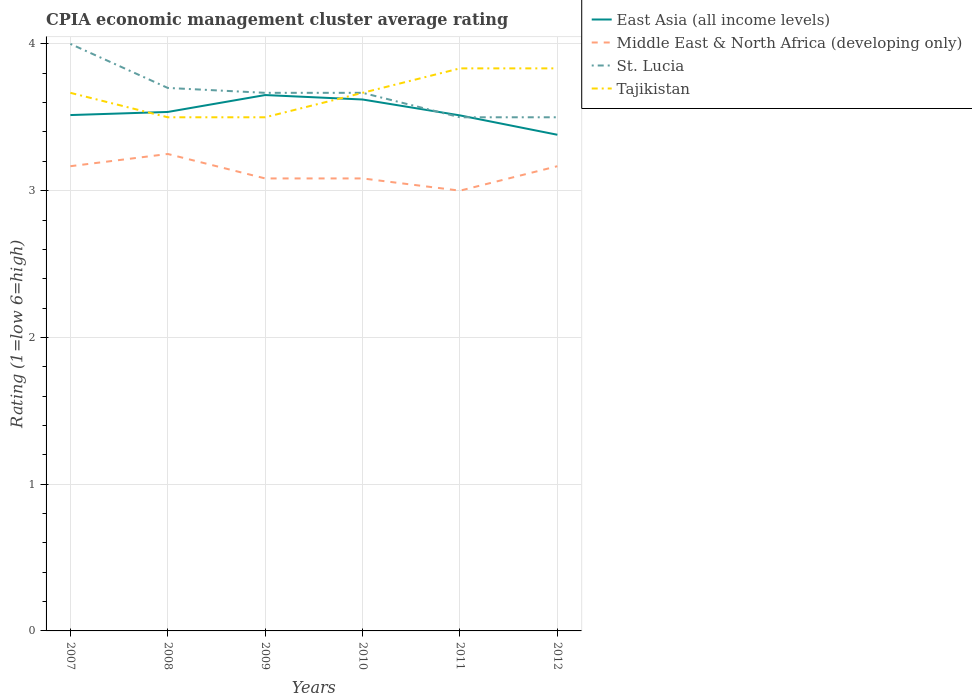Across all years, what is the maximum CPIA rating in St. Lucia?
Provide a short and direct response. 3.5. In which year was the CPIA rating in Middle East & North Africa (developing only) maximum?
Offer a terse response. 2011. What is the total CPIA rating in Tajikistan in the graph?
Give a very brief answer. -0.33. How many lines are there?
Your answer should be very brief. 4. How many years are there in the graph?
Your answer should be very brief. 6. Are the values on the major ticks of Y-axis written in scientific E-notation?
Give a very brief answer. No. Does the graph contain any zero values?
Provide a succinct answer. No. Where does the legend appear in the graph?
Your answer should be very brief. Top right. How many legend labels are there?
Your response must be concise. 4. What is the title of the graph?
Ensure brevity in your answer.  CPIA economic management cluster average rating. Does "Netherlands" appear as one of the legend labels in the graph?
Provide a succinct answer. No. What is the label or title of the X-axis?
Offer a terse response. Years. What is the Rating (1=low 6=high) of East Asia (all income levels) in 2007?
Your answer should be compact. 3.52. What is the Rating (1=low 6=high) of Middle East & North Africa (developing only) in 2007?
Your answer should be very brief. 3.17. What is the Rating (1=low 6=high) in Tajikistan in 2007?
Provide a succinct answer. 3.67. What is the Rating (1=low 6=high) of East Asia (all income levels) in 2008?
Your answer should be very brief. 3.54. What is the Rating (1=low 6=high) of St. Lucia in 2008?
Provide a short and direct response. 3.7. What is the Rating (1=low 6=high) in East Asia (all income levels) in 2009?
Your answer should be compact. 3.65. What is the Rating (1=low 6=high) in Middle East & North Africa (developing only) in 2009?
Your answer should be compact. 3.08. What is the Rating (1=low 6=high) in St. Lucia in 2009?
Give a very brief answer. 3.67. What is the Rating (1=low 6=high) of East Asia (all income levels) in 2010?
Keep it short and to the point. 3.62. What is the Rating (1=low 6=high) of Middle East & North Africa (developing only) in 2010?
Offer a very short reply. 3.08. What is the Rating (1=low 6=high) of St. Lucia in 2010?
Provide a succinct answer. 3.67. What is the Rating (1=low 6=high) of Tajikistan in 2010?
Your answer should be compact. 3.67. What is the Rating (1=low 6=high) of East Asia (all income levels) in 2011?
Provide a short and direct response. 3.51. What is the Rating (1=low 6=high) of St. Lucia in 2011?
Offer a very short reply. 3.5. What is the Rating (1=low 6=high) of Tajikistan in 2011?
Make the answer very short. 3.83. What is the Rating (1=low 6=high) of East Asia (all income levels) in 2012?
Ensure brevity in your answer.  3.38. What is the Rating (1=low 6=high) of Middle East & North Africa (developing only) in 2012?
Ensure brevity in your answer.  3.17. What is the Rating (1=low 6=high) in St. Lucia in 2012?
Provide a short and direct response. 3.5. What is the Rating (1=low 6=high) of Tajikistan in 2012?
Provide a short and direct response. 3.83. Across all years, what is the maximum Rating (1=low 6=high) in East Asia (all income levels)?
Offer a very short reply. 3.65. Across all years, what is the maximum Rating (1=low 6=high) of Tajikistan?
Provide a short and direct response. 3.83. Across all years, what is the minimum Rating (1=low 6=high) of East Asia (all income levels)?
Your answer should be very brief. 3.38. What is the total Rating (1=low 6=high) in East Asia (all income levels) in the graph?
Provide a short and direct response. 21.22. What is the total Rating (1=low 6=high) in Middle East & North Africa (developing only) in the graph?
Provide a short and direct response. 18.75. What is the total Rating (1=low 6=high) of St. Lucia in the graph?
Your response must be concise. 22.03. What is the difference between the Rating (1=low 6=high) of East Asia (all income levels) in 2007 and that in 2008?
Your answer should be compact. -0.02. What is the difference between the Rating (1=low 6=high) of Middle East & North Africa (developing only) in 2007 and that in 2008?
Make the answer very short. -0.08. What is the difference between the Rating (1=low 6=high) in Tajikistan in 2007 and that in 2008?
Offer a terse response. 0.17. What is the difference between the Rating (1=low 6=high) of East Asia (all income levels) in 2007 and that in 2009?
Your answer should be compact. -0.14. What is the difference between the Rating (1=low 6=high) of Middle East & North Africa (developing only) in 2007 and that in 2009?
Keep it short and to the point. 0.08. What is the difference between the Rating (1=low 6=high) of St. Lucia in 2007 and that in 2009?
Offer a very short reply. 0.33. What is the difference between the Rating (1=low 6=high) in East Asia (all income levels) in 2007 and that in 2010?
Provide a short and direct response. -0.11. What is the difference between the Rating (1=low 6=high) of Middle East & North Africa (developing only) in 2007 and that in 2010?
Keep it short and to the point. 0.08. What is the difference between the Rating (1=low 6=high) in St. Lucia in 2007 and that in 2010?
Your answer should be compact. 0.33. What is the difference between the Rating (1=low 6=high) of East Asia (all income levels) in 2007 and that in 2011?
Your answer should be very brief. 0. What is the difference between the Rating (1=low 6=high) in Middle East & North Africa (developing only) in 2007 and that in 2011?
Your answer should be compact. 0.17. What is the difference between the Rating (1=low 6=high) of St. Lucia in 2007 and that in 2011?
Ensure brevity in your answer.  0.5. What is the difference between the Rating (1=low 6=high) of East Asia (all income levels) in 2007 and that in 2012?
Offer a very short reply. 0.13. What is the difference between the Rating (1=low 6=high) in Tajikistan in 2007 and that in 2012?
Ensure brevity in your answer.  -0.17. What is the difference between the Rating (1=low 6=high) in East Asia (all income levels) in 2008 and that in 2009?
Provide a succinct answer. -0.12. What is the difference between the Rating (1=low 6=high) of St. Lucia in 2008 and that in 2009?
Offer a very short reply. 0.03. What is the difference between the Rating (1=low 6=high) in East Asia (all income levels) in 2008 and that in 2010?
Ensure brevity in your answer.  -0.08. What is the difference between the Rating (1=low 6=high) of St. Lucia in 2008 and that in 2010?
Give a very brief answer. 0.03. What is the difference between the Rating (1=low 6=high) in East Asia (all income levels) in 2008 and that in 2011?
Your answer should be compact. 0.02. What is the difference between the Rating (1=low 6=high) in Middle East & North Africa (developing only) in 2008 and that in 2011?
Provide a succinct answer. 0.25. What is the difference between the Rating (1=low 6=high) in St. Lucia in 2008 and that in 2011?
Offer a terse response. 0.2. What is the difference between the Rating (1=low 6=high) of Tajikistan in 2008 and that in 2011?
Give a very brief answer. -0.33. What is the difference between the Rating (1=low 6=high) of East Asia (all income levels) in 2008 and that in 2012?
Make the answer very short. 0.16. What is the difference between the Rating (1=low 6=high) of Middle East & North Africa (developing only) in 2008 and that in 2012?
Offer a terse response. 0.08. What is the difference between the Rating (1=low 6=high) in Tajikistan in 2008 and that in 2012?
Offer a terse response. -0.33. What is the difference between the Rating (1=low 6=high) in East Asia (all income levels) in 2009 and that in 2010?
Your answer should be compact. 0.03. What is the difference between the Rating (1=low 6=high) of Middle East & North Africa (developing only) in 2009 and that in 2010?
Ensure brevity in your answer.  0. What is the difference between the Rating (1=low 6=high) in Tajikistan in 2009 and that in 2010?
Keep it short and to the point. -0.17. What is the difference between the Rating (1=low 6=high) in East Asia (all income levels) in 2009 and that in 2011?
Your answer should be compact. 0.14. What is the difference between the Rating (1=low 6=high) in Middle East & North Africa (developing only) in 2009 and that in 2011?
Keep it short and to the point. 0.08. What is the difference between the Rating (1=low 6=high) in East Asia (all income levels) in 2009 and that in 2012?
Offer a very short reply. 0.27. What is the difference between the Rating (1=low 6=high) in Middle East & North Africa (developing only) in 2009 and that in 2012?
Your response must be concise. -0.08. What is the difference between the Rating (1=low 6=high) in St. Lucia in 2009 and that in 2012?
Offer a very short reply. 0.17. What is the difference between the Rating (1=low 6=high) in East Asia (all income levels) in 2010 and that in 2011?
Keep it short and to the point. 0.11. What is the difference between the Rating (1=low 6=high) in Middle East & North Africa (developing only) in 2010 and that in 2011?
Offer a terse response. 0.08. What is the difference between the Rating (1=low 6=high) in St. Lucia in 2010 and that in 2011?
Keep it short and to the point. 0.17. What is the difference between the Rating (1=low 6=high) of East Asia (all income levels) in 2010 and that in 2012?
Offer a terse response. 0.24. What is the difference between the Rating (1=low 6=high) of Middle East & North Africa (developing only) in 2010 and that in 2012?
Make the answer very short. -0.08. What is the difference between the Rating (1=low 6=high) of St. Lucia in 2010 and that in 2012?
Your response must be concise. 0.17. What is the difference between the Rating (1=low 6=high) of Tajikistan in 2010 and that in 2012?
Provide a short and direct response. -0.17. What is the difference between the Rating (1=low 6=high) in East Asia (all income levels) in 2011 and that in 2012?
Your answer should be compact. 0.13. What is the difference between the Rating (1=low 6=high) in St. Lucia in 2011 and that in 2012?
Give a very brief answer. 0. What is the difference between the Rating (1=low 6=high) in East Asia (all income levels) in 2007 and the Rating (1=low 6=high) in Middle East & North Africa (developing only) in 2008?
Provide a succinct answer. 0.27. What is the difference between the Rating (1=low 6=high) in East Asia (all income levels) in 2007 and the Rating (1=low 6=high) in St. Lucia in 2008?
Provide a succinct answer. -0.18. What is the difference between the Rating (1=low 6=high) of East Asia (all income levels) in 2007 and the Rating (1=low 6=high) of Tajikistan in 2008?
Make the answer very short. 0.02. What is the difference between the Rating (1=low 6=high) of Middle East & North Africa (developing only) in 2007 and the Rating (1=low 6=high) of St. Lucia in 2008?
Offer a very short reply. -0.53. What is the difference between the Rating (1=low 6=high) in Middle East & North Africa (developing only) in 2007 and the Rating (1=low 6=high) in Tajikistan in 2008?
Give a very brief answer. -0.33. What is the difference between the Rating (1=low 6=high) of St. Lucia in 2007 and the Rating (1=low 6=high) of Tajikistan in 2008?
Give a very brief answer. 0.5. What is the difference between the Rating (1=low 6=high) in East Asia (all income levels) in 2007 and the Rating (1=low 6=high) in Middle East & North Africa (developing only) in 2009?
Your answer should be very brief. 0.43. What is the difference between the Rating (1=low 6=high) in East Asia (all income levels) in 2007 and the Rating (1=low 6=high) in St. Lucia in 2009?
Your response must be concise. -0.15. What is the difference between the Rating (1=low 6=high) in East Asia (all income levels) in 2007 and the Rating (1=low 6=high) in Tajikistan in 2009?
Give a very brief answer. 0.02. What is the difference between the Rating (1=low 6=high) in Middle East & North Africa (developing only) in 2007 and the Rating (1=low 6=high) in Tajikistan in 2009?
Make the answer very short. -0.33. What is the difference between the Rating (1=low 6=high) of East Asia (all income levels) in 2007 and the Rating (1=low 6=high) of Middle East & North Africa (developing only) in 2010?
Offer a terse response. 0.43. What is the difference between the Rating (1=low 6=high) of East Asia (all income levels) in 2007 and the Rating (1=low 6=high) of St. Lucia in 2010?
Your response must be concise. -0.15. What is the difference between the Rating (1=low 6=high) of East Asia (all income levels) in 2007 and the Rating (1=low 6=high) of Tajikistan in 2010?
Your answer should be compact. -0.15. What is the difference between the Rating (1=low 6=high) of Middle East & North Africa (developing only) in 2007 and the Rating (1=low 6=high) of Tajikistan in 2010?
Your answer should be very brief. -0.5. What is the difference between the Rating (1=low 6=high) of St. Lucia in 2007 and the Rating (1=low 6=high) of Tajikistan in 2010?
Your response must be concise. 0.33. What is the difference between the Rating (1=low 6=high) of East Asia (all income levels) in 2007 and the Rating (1=low 6=high) of Middle East & North Africa (developing only) in 2011?
Offer a very short reply. 0.52. What is the difference between the Rating (1=low 6=high) in East Asia (all income levels) in 2007 and the Rating (1=low 6=high) in St. Lucia in 2011?
Offer a terse response. 0.02. What is the difference between the Rating (1=low 6=high) in East Asia (all income levels) in 2007 and the Rating (1=low 6=high) in Tajikistan in 2011?
Ensure brevity in your answer.  -0.32. What is the difference between the Rating (1=low 6=high) in Middle East & North Africa (developing only) in 2007 and the Rating (1=low 6=high) in Tajikistan in 2011?
Provide a short and direct response. -0.67. What is the difference between the Rating (1=low 6=high) in East Asia (all income levels) in 2007 and the Rating (1=low 6=high) in Middle East & North Africa (developing only) in 2012?
Offer a terse response. 0.35. What is the difference between the Rating (1=low 6=high) in East Asia (all income levels) in 2007 and the Rating (1=low 6=high) in St. Lucia in 2012?
Your answer should be very brief. 0.02. What is the difference between the Rating (1=low 6=high) in East Asia (all income levels) in 2007 and the Rating (1=low 6=high) in Tajikistan in 2012?
Give a very brief answer. -0.32. What is the difference between the Rating (1=low 6=high) in Middle East & North Africa (developing only) in 2007 and the Rating (1=low 6=high) in Tajikistan in 2012?
Your response must be concise. -0.67. What is the difference between the Rating (1=low 6=high) in East Asia (all income levels) in 2008 and the Rating (1=low 6=high) in Middle East & North Africa (developing only) in 2009?
Make the answer very short. 0.45. What is the difference between the Rating (1=low 6=high) of East Asia (all income levels) in 2008 and the Rating (1=low 6=high) of St. Lucia in 2009?
Give a very brief answer. -0.13. What is the difference between the Rating (1=low 6=high) of East Asia (all income levels) in 2008 and the Rating (1=low 6=high) of Tajikistan in 2009?
Give a very brief answer. 0.04. What is the difference between the Rating (1=low 6=high) in Middle East & North Africa (developing only) in 2008 and the Rating (1=low 6=high) in St. Lucia in 2009?
Provide a succinct answer. -0.42. What is the difference between the Rating (1=low 6=high) in St. Lucia in 2008 and the Rating (1=low 6=high) in Tajikistan in 2009?
Ensure brevity in your answer.  0.2. What is the difference between the Rating (1=low 6=high) in East Asia (all income levels) in 2008 and the Rating (1=low 6=high) in Middle East & North Africa (developing only) in 2010?
Offer a terse response. 0.45. What is the difference between the Rating (1=low 6=high) of East Asia (all income levels) in 2008 and the Rating (1=low 6=high) of St. Lucia in 2010?
Provide a succinct answer. -0.13. What is the difference between the Rating (1=low 6=high) in East Asia (all income levels) in 2008 and the Rating (1=low 6=high) in Tajikistan in 2010?
Give a very brief answer. -0.13. What is the difference between the Rating (1=low 6=high) in Middle East & North Africa (developing only) in 2008 and the Rating (1=low 6=high) in St. Lucia in 2010?
Your answer should be compact. -0.42. What is the difference between the Rating (1=low 6=high) in Middle East & North Africa (developing only) in 2008 and the Rating (1=low 6=high) in Tajikistan in 2010?
Provide a succinct answer. -0.42. What is the difference between the Rating (1=low 6=high) in East Asia (all income levels) in 2008 and the Rating (1=low 6=high) in Middle East & North Africa (developing only) in 2011?
Give a very brief answer. 0.54. What is the difference between the Rating (1=low 6=high) in East Asia (all income levels) in 2008 and the Rating (1=low 6=high) in St. Lucia in 2011?
Your answer should be compact. 0.04. What is the difference between the Rating (1=low 6=high) of East Asia (all income levels) in 2008 and the Rating (1=low 6=high) of Tajikistan in 2011?
Ensure brevity in your answer.  -0.3. What is the difference between the Rating (1=low 6=high) in Middle East & North Africa (developing only) in 2008 and the Rating (1=low 6=high) in St. Lucia in 2011?
Offer a very short reply. -0.25. What is the difference between the Rating (1=low 6=high) of Middle East & North Africa (developing only) in 2008 and the Rating (1=low 6=high) of Tajikistan in 2011?
Offer a terse response. -0.58. What is the difference between the Rating (1=low 6=high) in St. Lucia in 2008 and the Rating (1=low 6=high) in Tajikistan in 2011?
Ensure brevity in your answer.  -0.13. What is the difference between the Rating (1=low 6=high) in East Asia (all income levels) in 2008 and the Rating (1=low 6=high) in Middle East & North Africa (developing only) in 2012?
Give a very brief answer. 0.37. What is the difference between the Rating (1=low 6=high) in East Asia (all income levels) in 2008 and the Rating (1=low 6=high) in St. Lucia in 2012?
Provide a succinct answer. 0.04. What is the difference between the Rating (1=low 6=high) of East Asia (all income levels) in 2008 and the Rating (1=low 6=high) of Tajikistan in 2012?
Ensure brevity in your answer.  -0.3. What is the difference between the Rating (1=low 6=high) in Middle East & North Africa (developing only) in 2008 and the Rating (1=low 6=high) in St. Lucia in 2012?
Keep it short and to the point. -0.25. What is the difference between the Rating (1=low 6=high) of Middle East & North Africa (developing only) in 2008 and the Rating (1=low 6=high) of Tajikistan in 2012?
Provide a short and direct response. -0.58. What is the difference between the Rating (1=low 6=high) of St. Lucia in 2008 and the Rating (1=low 6=high) of Tajikistan in 2012?
Your answer should be compact. -0.13. What is the difference between the Rating (1=low 6=high) of East Asia (all income levels) in 2009 and the Rating (1=low 6=high) of Middle East & North Africa (developing only) in 2010?
Your answer should be very brief. 0.57. What is the difference between the Rating (1=low 6=high) in East Asia (all income levels) in 2009 and the Rating (1=low 6=high) in St. Lucia in 2010?
Provide a short and direct response. -0.02. What is the difference between the Rating (1=low 6=high) in East Asia (all income levels) in 2009 and the Rating (1=low 6=high) in Tajikistan in 2010?
Provide a short and direct response. -0.02. What is the difference between the Rating (1=low 6=high) of Middle East & North Africa (developing only) in 2009 and the Rating (1=low 6=high) of St. Lucia in 2010?
Provide a succinct answer. -0.58. What is the difference between the Rating (1=low 6=high) of Middle East & North Africa (developing only) in 2009 and the Rating (1=low 6=high) of Tajikistan in 2010?
Your response must be concise. -0.58. What is the difference between the Rating (1=low 6=high) of East Asia (all income levels) in 2009 and the Rating (1=low 6=high) of Middle East & North Africa (developing only) in 2011?
Ensure brevity in your answer.  0.65. What is the difference between the Rating (1=low 6=high) of East Asia (all income levels) in 2009 and the Rating (1=low 6=high) of St. Lucia in 2011?
Your response must be concise. 0.15. What is the difference between the Rating (1=low 6=high) of East Asia (all income levels) in 2009 and the Rating (1=low 6=high) of Tajikistan in 2011?
Keep it short and to the point. -0.18. What is the difference between the Rating (1=low 6=high) of Middle East & North Africa (developing only) in 2009 and the Rating (1=low 6=high) of St. Lucia in 2011?
Ensure brevity in your answer.  -0.42. What is the difference between the Rating (1=low 6=high) in Middle East & North Africa (developing only) in 2009 and the Rating (1=low 6=high) in Tajikistan in 2011?
Make the answer very short. -0.75. What is the difference between the Rating (1=low 6=high) in East Asia (all income levels) in 2009 and the Rating (1=low 6=high) in Middle East & North Africa (developing only) in 2012?
Your response must be concise. 0.48. What is the difference between the Rating (1=low 6=high) of East Asia (all income levels) in 2009 and the Rating (1=low 6=high) of St. Lucia in 2012?
Ensure brevity in your answer.  0.15. What is the difference between the Rating (1=low 6=high) in East Asia (all income levels) in 2009 and the Rating (1=low 6=high) in Tajikistan in 2012?
Offer a very short reply. -0.18. What is the difference between the Rating (1=low 6=high) in Middle East & North Africa (developing only) in 2009 and the Rating (1=low 6=high) in St. Lucia in 2012?
Provide a short and direct response. -0.42. What is the difference between the Rating (1=low 6=high) of Middle East & North Africa (developing only) in 2009 and the Rating (1=low 6=high) of Tajikistan in 2012?
Your response must be concise. -0.75. What is the difference between the Rating (1=low 6=high) in St. Lucia in 2009 and the Rating (1=low 6=high) in Tajikistan in 2012?
Your answer should be very brief. -0.17. What is the difference between the Rating (1=low 6=high) in East Asia (all income levels) in 2010 and the Rating (1=low 6=high) in Middle East & North Africa (developing only) in 2011?
Provide a short and direct response. 0.62. What is the difference between the Rating (1=low 6=high) of East Asia (all income levels) in 2010 and the Rating (1=low 6=high) of St. Lucia in 2011?
Offer a terse response. 0.12. What is the difference between the Rating (1=low 6=high) of East Asia (all income levels) in 2010 and the Rating (1=low 6=high) of Tajikistan in 2011?
Your answer should be compact. -0.21. What is the difference between the Rating (1=low 6=high) of Middle East & North Africa (developing only) in 2010 and the Rating (1=low 6=high) of St. Lucia in 2011?
Your answer should be very brief. -0.42. What is the difference between the Rating (1=low 6=high) in Middle East & North Africa (developing only) in 2010 and the Rating (1=low 6=high) in Tajikistan in 2011?
Your answer should be very brief. -0.75. What is the difference between the Rating (1=low 6=high) of East Asia (all income levels) in 2010 and the Rating (1=low 6=high) of Middle East & North Africa (developing only) in 2012?
Your response must be concise. 0.45. What is the difference between the Rating (1=low 6=high) in East Asia (all income levels) in 2010 and the Rating (1=low 6=high) in St. Lucia in 2012?
Keep it short and to the point. 0.12. What is the difference between the Rating (1=low 6=high) in East Asia (all income levels) in 2010 and the Rating (1=low 6=high) in Tajikistan in 2012?
Your response must be concise. -0.21. What is the difference between the Rating (1=low 6=high) of Middle East & North Africa (developing only) in 2010 and the Rating (1=low 6=high) of St. Lucia in 2012?
Your response must be concise. -0.42. What is the difference between the Rating (1=low 6=high) of Middle East & North Africa (developing only) in 2010 and the Rating (1=low 6=high) of Tajikistan in 2012?
Offer a very short reply. -0.75. What is the difference between the Rating (1=low 6=high) of East Asia (all income levels) in 2011 and the Rating (1=low 6=high) of Middle East & North Africa (developing only) in 2012?
Keep it short and to the point. 0.35. What is the difference between the Rating (1=low 6=high) of East Asia (all income levels) in 2011 and the Rating (1=low 6=high) of St. Lucia in 2012?
Your response must be concise. 0.01. What is the difference between the Rating (1=low 6=high) of East Asia (all income levels) in 2011 and the Rating (1=low 6=high) of Tajikistan in 2012?
Keep it short and to the point. -0.32. What is the difference between the Rating (1=low 6=high) of Middle East & North Africa (developing only) in 2011 and the Rating (1=low 6=high) of Tajikistan in 2012?
Give a very brief answer. -0.83. What is the average Rating (1=low 6=high) of East Asia (all income levels) per year?
Your answer should be very brief. 3.54. What is the average Rating (1=low 6=high) of Middle East & North Africa (developing only) per year?
Provide a short and direct response. 3.12. What is the average Rating (1=low 6=high) in St. Lucia per year?
Your answer should be very brief. 3.67. What is the average Rating (1=low 6=high) of Tajikistan per year?
Offer a very short reply. 3.67. In the year 2007, what is the difference between the Rating (1=low 6=high) of East Asia (all income levels) and Rating (1=low 6=high) of Middle East & North Africa (developing only)?
Offer a terse response. 0.35. In the year 2007, what is the difference between the Rating (1=low 6=high) of East Asia (all income levels) and Rating (1=low 6=high) of St. Lucia?
Your answer should be very brief. -0.48. In the year 2007, what is the difference between the Rating (1=low 6=high) in East Asia (all income levels) and Rating (1=low 6=high) in Tajikistan?
Your answer should be compact. -0.15. In the year 2007, what is the difference between the Rating (1=low 6=high) of Middle East & North Africa (developing only) and Rating (1=low 6=high) of Tajikistan?
Your response must be concise. -0.5. In the year 2007, what is the difference between the Rating (1=low 6=high) of St. Lucia and Rating (1=low 6=high) of Tajikistan?
Offer a very short reply. 0.33. In the year 2008, what is the difference between the Rating (1=low 6=high) in East Asia (all income levels) and Rating (1=low 6=high) in Middle East & North Africa (developing only)?
Give a very brief answer. 0.29. In the year 2008, what is the difference between the Rating (1=low 6=high) in East Asia (all income levels) and Rating (1=low 6=high) in St. Lucia?
Keep it short and to the point. -0.16. In the year 2008, what is the difference between the Rating (1=low 6=high) of East Asia (all income levels) and Rating (1=low 6=high) of Tajikistan?
Give a very brief answer. 0.04. In the year 2008, what is the difference between the Rating (1=low 6=high) in Middle East & North Africa (developing only) and Rating (1=low 6=high) in St. Lucia?
Make the answer very short. -0.45. In the year 2008, what is the difference between the Rating (1=low 6=high) of St. Lucia and Rating (1=low 6=high) of Tajikistan?
Offer a terse response. 0.2. In the year 2009, what is the difference between the Rating (1=low 6=high) of East Asia (all income levels) and Rating (1=low 6=high) of Middle East & North Africa (developing only)?
Keep it short and to the point. 0.57. In the year 2009, what is the difference between the Rating (1=low 6=high) of East Asia (all income levels) and Rating (1=low 6=high) of St. Lucia?
Provide a short and direct response. -0.02. In the year 2009, what is the difference between the Rating (1=low 6=high) in East Asia (all income levels) and Rating (1=low 6=high) in Tajikistan?
Make the answer very short. 0.15. In the year 2009, what is the difference between the Rating (1=low 6=high) in Middle East & North Africa (developing only) and Rating (1=low 6=high) in St. Lucia?
Your answer should be very brief. -0.58. In the year 2009, what is the difference between the Rating (1=low 6=high) in Middle East & North Africa (developing only) and Rating (1=low 6=high) in Tajikistan?
Keep it short and to the point. -0.42. In the year 2010, what is the difference between the Rating (1=low 6=high) of East Asia (all income levels) and Rating (1=low 6=high) of Middle East & North Africa (developing only)?
Make the answer very short. 0.54. In the year 2010, what is the difference between the Rating (1=low 6=high) in East Asia (all income levels) and Rating (1=low 6=high) in St. Lucia?
Make the answer very short. -0.05. In the year 2010, what is the difference between the Rating (1=low 6=high) of East Asia (all income levels) and Rating (1=low 6=high) of Tajikistan?
Your response must be concise. -0.05. In the year 2010, what is the difference between the Rating (1=low 6=high) in Middle East & North Africa (developing only) and Rating (1=low 6=high) in St. Lucia?
Provide a short and direct response. -0.58. In the year 2010, what is the difference between the Rating (1=low 6=high) of Middle East & North Africa (developing only) and Rating (1=low 6=high) of Tajikistan?
Your answer should be very brief. -0.58. In the year 2010, what is the difference between the Rating (1=low 6=high) in St. Lucia and Rating (1=low 6=high) in Tajikistan?
Provide a succinct answer. 0. In the year 2011, what is the difference between the Rating (1=low 6=high) in East Asia (all income levels) and Rating (1=low 6=high) in Middle East & North Africa (developing only)?
Your answer should be very brief. 0.51. In the year 2011, what is the difference between the Rating (1=low 6=high) of East Asia (all income levels) and Rating (1=low 6=high) of St. Lucia?
Give a very brief answer. 0.01. In the year 2011, what is the difference between the Rating (1=low 6=high) in East Asia (all income levels) and Rating (1=low 6=high) in Tajikistan?
Make the answer very short. -0.32. In the year 2011, what is the difference between the Rating (1=low 6=high) in Middle East & North Africa (developing only) and Rating (1=low 6=high) in Tajikistan?
Offer a terse response. -0.83. In the year 2011, what is the difference between the Rating (1=low 6=high) of St. Lucia and Rating (1=low 6=high) of Tajikistan?
Give a very brief answer. -0.33. In the year 2012, what is the difference between the Rating (1=low 6=high) in East Asia (all income levels) and Rating (1=low 6=high) in Middle East & North Africa (developing only)?
Ensure brevity in your answer.  0.21. In the year 2012, what is the difference between the Rating (1=low 6=high) of East Asia (all income levels) and Rating (1=low 6=high) of St. Lucia?
Make the answer very short. -0.12. In the year 2012, what is the difference between the Rating (1=low 6=high) in East Asia (all income levels) and Rating (1=low 6=high) in Tajikistan?
Offer a terse response. -0.45. In the year 2012, what is the difference between the Rating (1=low 6=high) in Middle East & North Africa (developing only) and Rating (1=low 6=high) in St. Lucia?
Offer a very short reply. -0.33. In the year 2012, what is the difference between the Rating (1=low 6=high) in Middle East & North Africa (developing only) and Rating (1=low 6=high) in Tajikistan?
Make the answer very short. -0.67. In the year 2012, what is the difference between the Rating (1=low 6=high) of St. Lucia and Rating (1=low 6=high) of Tajikistan?
Offer a very short reply. -0.33. What is the ratio of the Rating (1=low 6=high) of East Asia (all income levels) in 2007 to that in 2008?
Offer a very short reply. 0.99. What is the ratio of the Rating (1=low 6=high) of Middle East & North Africa (developing only) in 2007 to that in 2008?
Provide a short and direct response. 0.97. What is the ratio of the Rating (1=low 6=high) of St. Lucia in 2007 to that in 2008?
Your answer should be very brief. 1.08. What is the ratio of the Rating (1=low 6=high) in Tajikistan in 2007 to that in 2008?
Keep it short and to the point. 1.05. What is the ratio of the Rating (1=low 6=high) in East Asia (all income levels) in 2007 to that in 2009?
Your answer should be very brief. 0.96. What is the ratio of the Rating (1=low 6=high) of Middle East & North Africa (developing only) in 2007 to that in 2009?
Keep it short and to the point. 1.03. What is the ratio of the Rating (1=low 6=high) of St. Lucia in 2007 to that in 2009?
Offer a terse response. 1.09. What is the ratio of the Rating (1=low 6=high) in Tajikistan in 2007 to that in 2009?
Make the answer very short. 1.05. What is the ratio of the Rating (1=low 6=high) of East Asia (all income levels) in 2007 to that in 2010?
Make the answer very short. 0.97. What is the ratio of the Rating (1=low 6=high) of Tajikistan in 2007 to that in 2010?
Provide a short and direct response. 1. What is the ratio of the Rating (1=low 6=high) of Middle East & North Africa (developing only) in 2007 to that in 2011?
Give a very brief answer. 1.06. What is the ratio of the Rating (1=low 6=high) of St. Lucia in 2007 to that in 2011?
Provide a succinct answer. 1.14. What is the ratio of the Rating (1=low 6=high) of Tajikistan in 2007 to that in 2011?
Your answer should be very brief. 0.96. What is the ratio of the Rating (1=low 6=high) of East Asia (all income levels) in 2007 to that in 2012?
Your response must be concise. 1.04. What is the ratio of the Rating (1=low 6=high) of Middle East & North Africa (developing only) in 2007 to that in 2012?
Provide a short and direct response. 1. What is the ratio of the Rating (1=low 6=high) of Tajikistan in 2007 to that in 2012?
Provide a succinct answer. 0.96. What is the ratio of the Rating (1=low 6=high) in East Asia (all income levels) in 2008 to that in 2009?
Provide a succinct answer. 0.97. What is the ratio of the Rating (1=low 6=high) of Middle East & North Africa (developing only) in 2008 to that in 2009?
Provide a succinct answer. 1.05. What is the ratio of the Rating (1=low 6=high) in St. Lucia in 2008 to that in 2009?
Offer a very short reply. 1.01. What is the ratio of the Rating (1=low 6=high) in East Asia (all income levels) in 2008 to that in 2010?
Your answer should be very brief. 0.98. What is the ratio of the Rating (1=low 6=high) in Middle East & North Africa (developing only) in 2008 to that in 2010?
Provide a short and direct response. 1.05. What is the ratio of the Rating (1=low 6=high) in St. Lucia in 2008 to that in 2010?
Offer a terse response. 1.01. What is the ratio of the Rating (1=low 6=high) in Tajikistan in 2008 to that in 2010?
Ensure brevity in your answer.  0.95. What is the ratio of the Rating (1=low 6=high) of East Asia (all income levels) in 2008 to that in 2011?
Offer a terse response. 1.01. What is the ratio of the Rating (1=low 6=high) of St. Lucia in 2008 to that in 2011?
Keep it short and to the point. 1.06. What is the ratio of the Rating (1=low 6=high) of East Asia (all income levels) in 2008 to that in 2012?
Keep it short and to the point. 1.05. What is the ratio of the Rating (1=low 6=high) in Middle East & North Africa (developing only) in 2008 to that in 2012?
Ensure brevity in your answer.  1.03. What is the ratio of the Rating (1=low 6=high) of St. Lucia in 2008 to that in 2012?
Keep it short and to the point. 1.06. What is the ratio of the Rating (1=low 6=high) of Tajikistan in 2008 to that in 2012?
Your answer should be very brief. 0.91. What is the ratio of the Rating (1=low 6=high) of East Asia (all income levels) in 2009 to that in 2010?
Your answer should be compact. 1.01. What is the ratio of the Rating (1=low 6=high) of Middle East & North Africa (developing only) in 2009 to that in 2010?
Ensure brevity in your answer.  1. What is the ratio of the Rating (1=low 6=high) in St. Lucia in 2009 to that in 2010?
Your response must be concise. 1. What is the ratio of the Rating (1=low 6=high) of Tajikistan in 2009 to that in 2010?
Give a very brief answer. 0.95. What is the ratio of the Rating (1=low 6=high) of East Asia (all income levels) in 2009 to that in 2011?
Provide a short and direct response. 1.04. What is the ratio of the Rating (1=low 6=high) of Middle East & North Africa (developing only) in 2009 to that in 2011?
Give a very brief answer. 1.03. What is the ratio of the Rating (1=low 6=high) in St. Lucia in 2009 to that in 2011?
Ensure brevity in your answer.  1.05. What is the ratio of the Rating (1=low 6=high) of Middle East & North Africa (developing only) in 2009 to that in 2012?
Offer a terse response. 0.97. What is the ratio of the Rating (1=low 6=high) of St. Lucia in 2009 to that in 2012?
Offer a very short reply. 1.05. What is the ratio of the Rating (1=low 6=high) in East Asia (all income levels) in 2010 to that in 2011?
Offer a very short reply. 1.03. What is the ratio of the Rating (1=low 6=high) in Middle East & North Africa (developing only) in 2010 to that in 2011?
Offer a very short reply. 1.03. What is the ratio of the Rating (1=low 6=high) in St. Lucia in 2010 to that in 2011?
Your answer should be compact. 1.05. What is the ratio of the Rating (1=low 6=high) of Tajikistan in 2010 to that in 2011?
Your response must be concise. 0.96. What is the ratio of the Rating (1=low 6=high) of East Asia (all income levels) in 2010 to that in 2012?
Offer a very short reply. 1.07. What is the ratio of the Rating (1=low 6=high) in Middle East & North Africa (developing only) in 2010 to that in 2012?
Offer a terse response. 0.97. What is the ratio of the Rating (1=low 6=high) of St. Lucia in 2010 to that in 2012?
Your response must be concise. 1.05. What is the ratio of the Rating (1=low 6=high) in Tajikistan in 2010 to that in 2012?
Provide a short and direct response. 0.96. What is the ratio of the Rating (1=low 6=high) of East Asia (all income levels) in 2011 to that in 2012?
Provide a short and direct response. 1.04. What is the ratio of the Rating (1=low 6=high) of St. Lucia in 2011 to that in 2012?
Provide a succinct answer. 1. What is the ratio of the Rating (1=low 6=high) in Tajikistan in 2011 to that in 2012?
Your answer should be compact. 1. What is the difference between the highest and the second highest Rating (1=low 6=high) of East Asia (all income levels)?
Your response must be concise. 0.03. What is the difference between the highest and the second highest Rating (1=low 6=high) in Middle East & North Africa (developing only)?
Make the answer very short. 0.08. What is the difference between the highest and the second highest Rating (1=low 6=high) in Tajikistan?
Ensure brevity in your answer.  0. What is the difference between the highest and the lowest Rating (1=low 6=high) in East Asia (all income levels)?
Ensure brevity in your answer.  0.27. What is the difference between the highest and the lowest Rating (1=low 6=high) of St. Lucia?
Your answer should be very brief. 0.5. What is the difference between the highest and the lowest Rating (1=low 6=high) of Tajikistan?
Ensure brevity in your answer.  0.33. 